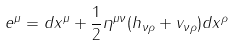<formula> <loc_0><loc_0><loc_500><loc_500>e ^ { \mu } = d x ^ { \mu } + \frac { 1 } { 2 } \eta ^ { \mu \nu } ( h _ { \nu \rho } + v _ { \nu \rho } ) d x ^ { \rho }</formula> 